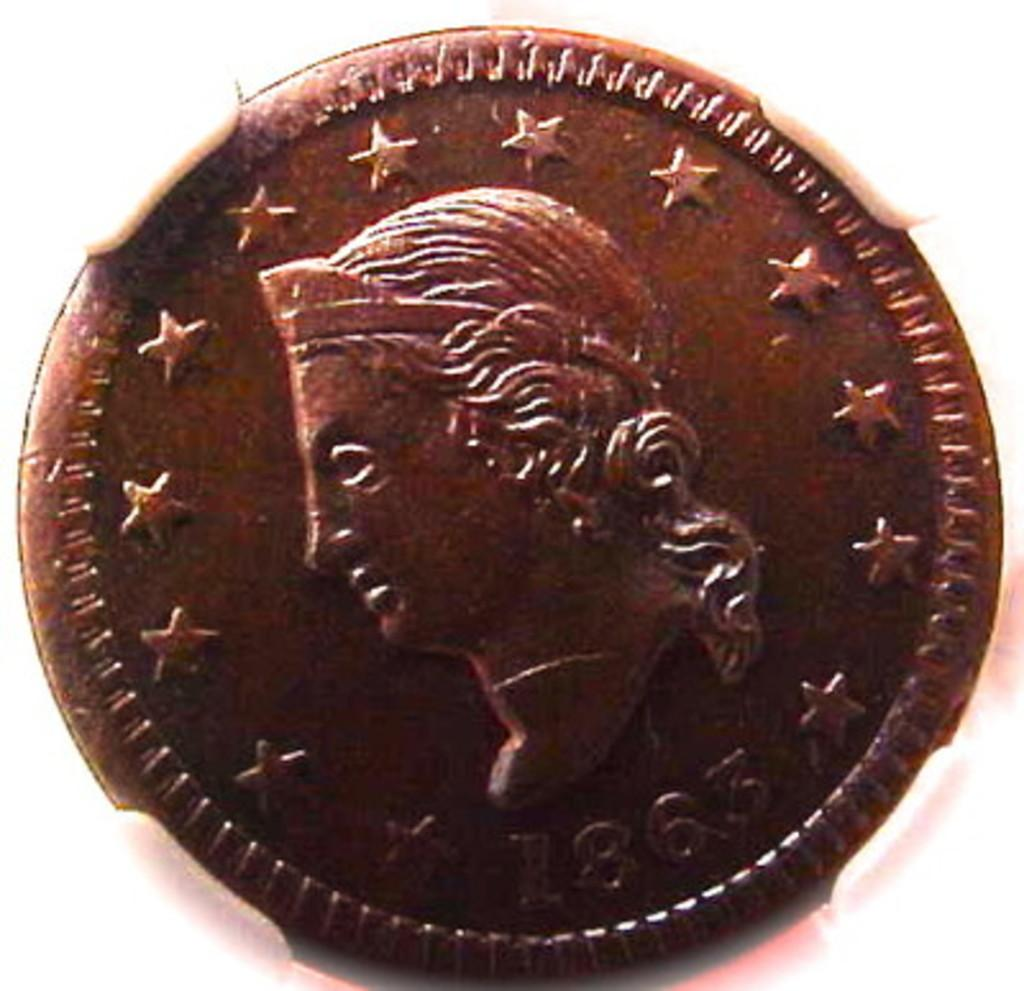Provide a one-sentence caption for the provided image. A blurry shot of an old coin dated from the year 1863. 